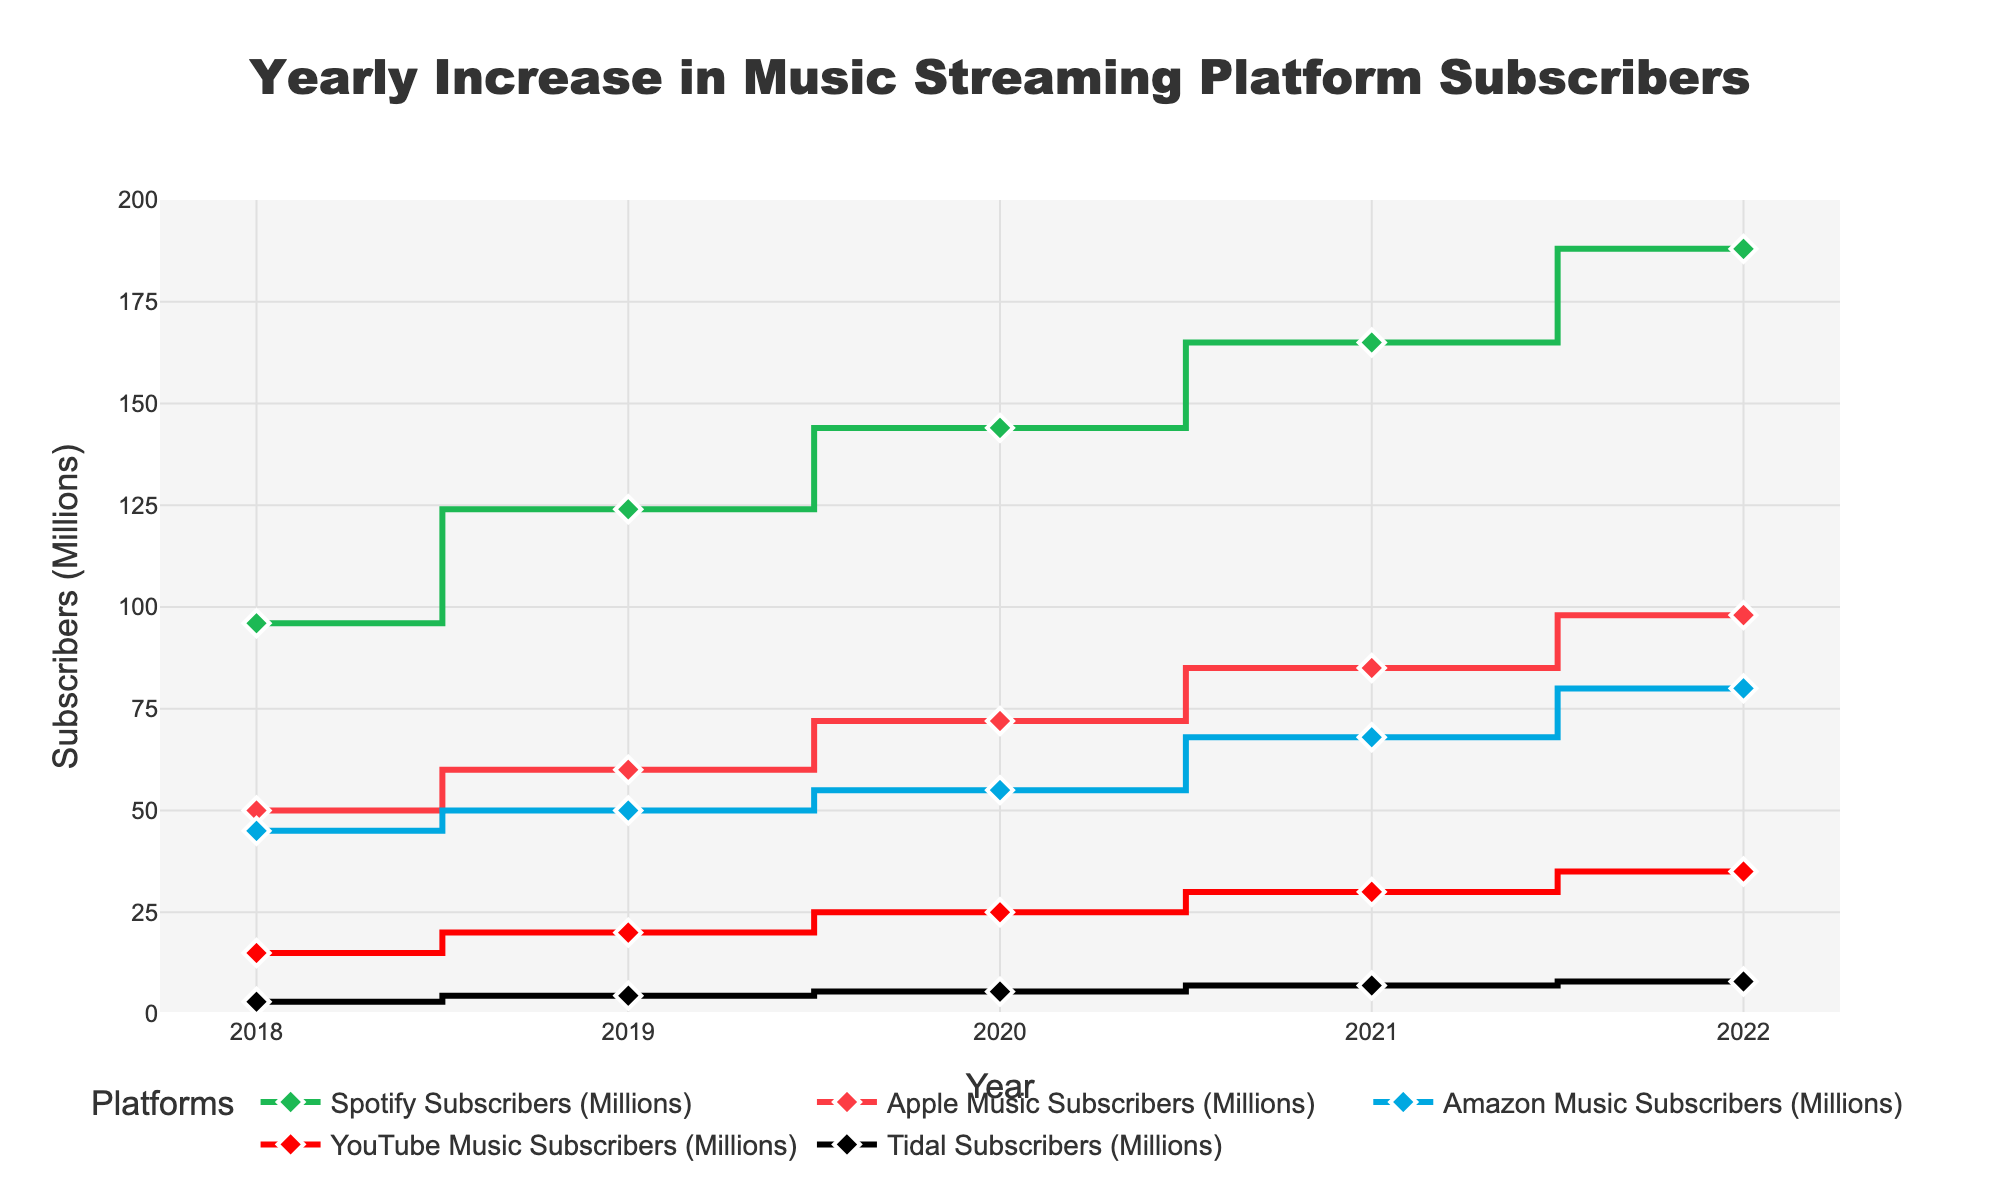What is the title of the plot? The title is located at the top center of the plot and gives a concise description of the data being visualized. Here, it states 'Yearly Increase in Music Streaming Platform Subscribers'.
Answer: Yearly Increase in Music Streaming Platform Subscribers How many data points are plotted for each platform? Each platform has a data point for every year from 2018 to 2022. Counting these data points, we see that each platform has 5 data points (one for each year).
Answer: 5 What is the range of the y-axis representing subscribers in millions? The y-axis range can be seen on the left of the plot, and it starts at 0 and goes up to 200.
Answer: 0 to 200 Which platform had the highest subscriber count in 2022? By looking at the values for the year 2022 across all platforms, we see that Spotify had the highest with 188 million subscribers.
Answer: Spotify By how much did Spotify's subscribers increase from 2018 to 2022? To find the growth, subtract Spotify's subscriber count in 2018 from its count in 2022: 188 million - 96 million = 92 million.
Answer: 92 million Which platform saw the smallest increase in subscribers from 2018 to 2022? Calculate the difference for each platform between 2018 and 2022. Tidal's increase is from 3 million to 8 million, hence 5 million, which is the smallest increase.
Answer: Tidal In which year did Amazon Music surpass the 50 million subscriber mark? Look for the year where Amazon Music subscribers first exceed 50 million. It happened in 2021 when Amazon Music had 55 million subscribers.
Answer: 2021 What is the total number of YouTube Music subscribers across all the years? Add the subscribers for YouTube Music from each year: 15M (2018) + 20M (2019) + 25M (2020) + 30M (2021) + 35M (2022) = 125 million.
Answer: 125 million Which two platforms had the closest subscriber counts in 2021, and what were those counts? Compare the subscriber counts in 2021; Apple Music had 85 million and Amazon Music had 68 million. The closest values were between Tidal (7 million) and YouTube Music (30 million) where the difference is 23 million which is the smallest among others.
Answer: Tidal (7 million) and YouTube Music (30 million) 